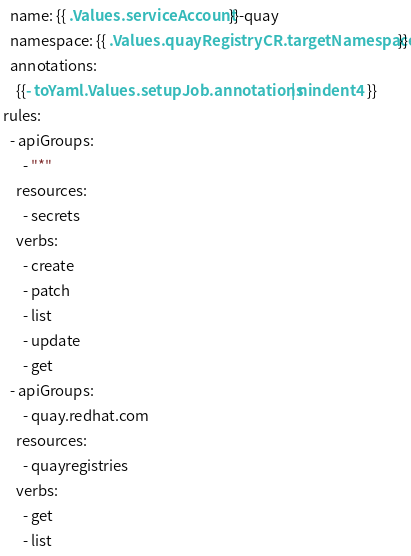Convert code to text. <code><loc_0><loc_0><loc_500><loc_500><_YAML_>  name: {{ .Values.serviceAccount }}-quay
  namespace: {{ .Values.quayRegistryCR.targetNamespace }}
  annotations:
    {{- toYaml .Values.setupJob.annotations | nindent 4 }}  
rules:
  - apiGroups:
      - "*"
    resources:
      - secrets
    verbs:
      - create
      - patch
      - list
      - update
      - get
  - apiGroups:
      - quay.redhat.com
    resources:
      - quayregistries
    verbs:
      - get
      - list
</code> 